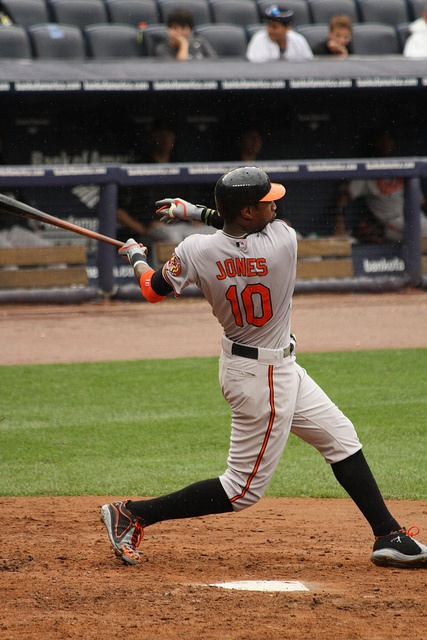Describe the objects in this image and their specific colors. I can see people in purple, black, darkgray, lightgray, and gray tones, people in purple, lightgray, darkgray, gray, and black tones, people in purple, gray, black, and maroon tones, baseball bat in purple, black, gray, maroon, and darkgray tones, and people in purple, gray, brown, and black tones in this image. 